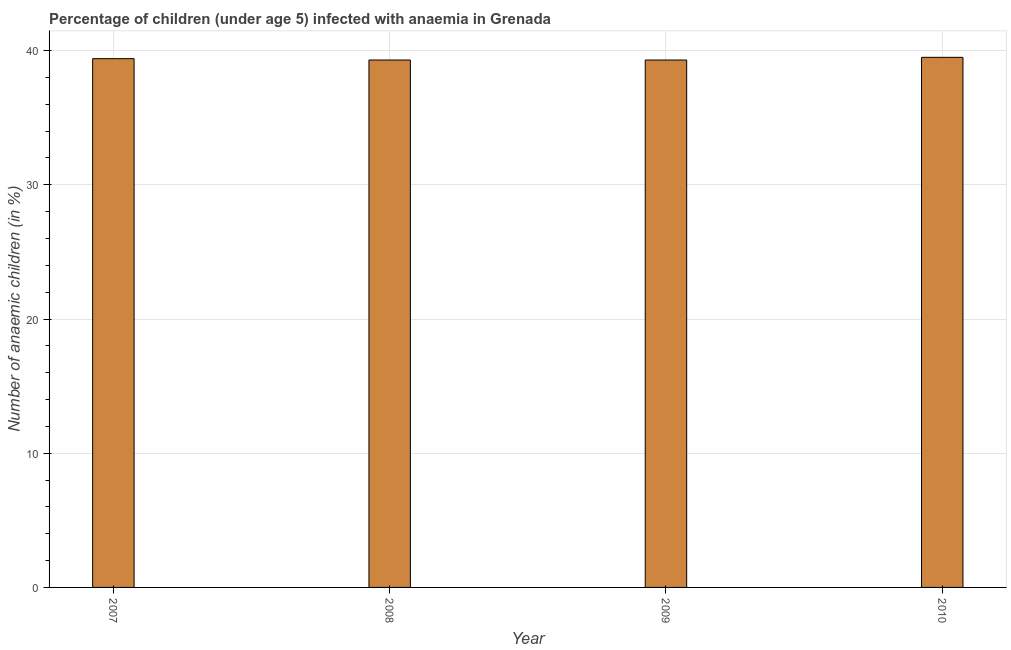What is the title of the graph?
Your answer should be very brief. Percentage of children (under age 5) infected with anaemia in Grenada. What is the label or title of the X-axis?
Provide a succinct answer. Year. What is the label or title of the Y-axis?
Your response must be concise. Number of anaemic children (in %). What is the number of anaemic children in 2008?
Offer a very short reply. 39.3. Across all years, what is the maximum number of anaemic children?
Your answer should be compact. 39.5. Across all years, what is the minimum number of anaemic children?
Your answer should be very brief. 39.3. In which year was the number of anaemic children minimum?
Provide a succinct answer. 2008. What is the sum of the number of anaemic children?
Keep it short and to the point. 157.5. What is the difference between the number of anaemic children in 2008 and 2009?
Offer a terse response. 0. What is the average number of anaemic children per year?
Offer a very short reply. 39.38. What is the median number of anaemic children?
Offer a very short reply. 39.35. Do a majority of the years between 2008 and 2010 (inclusive) have number of anaemic children greater than 26 %?
Keep it short and to the point. Yes. Is the number of anaemic children in 2008 less than that in 2010?
Ensure brevity in your answer.  Yes. What is the difference between the highest and the second highest number of anaemic children?
Offer a very short reply. 0.1. Is the sum of the number of anaemic children in 2008 and 2010 greater than the maximum number of anaemic children across all years?
Keep it short and to the point. Yes. In how many years, is the number of anaemic children greater than the average number of anaemic children taken over all years?
Provide a short and direct response. 2. How many bars are there?
Your answer should be very brief. 4. Are all the bars in the graph horizontal?
Offer a terse response. No. What is the difference between two consecutive major ticks on the Y-axis?
Provide a succinct answer. 10. Are the values on the major ticks of Y-axis written in scientific E-notation?
Keep it short and to the point. No. What is the Number of anaemic children (in %) in 2007?
Your response must be concise. 39.4. What is the Number of anaemic children (in %) in 2008?
Keep it short and to the point. 39.3. What is the Number of anaemic children (in %) in 2009?
Provide a short and direct response. 39.3. What is the Number of anaemic children (in %) in 2010?
Your response must be concise. 39.5. What is the difference between the Number of anaemic children (in %) in 2007 and 2009?
Ensure brevity in your answer.  0.1. What is the difference between the Number of anaemic children (in %) in 2008 and 2010?
Keep it short and to the point. -0.2. What is the difference between the Number of anaemic children (in %) in 2009 and 2010?
Offer a very short reply. -0.2. What is the ratio of the Number of anaemic children (in %) in 2007 to that in 2008?
Offer a very short reply. 1. What is the ratio of the Number of anaemic children (in %) in 2008 to that in 2009?
Give a very brief answer. 1. 